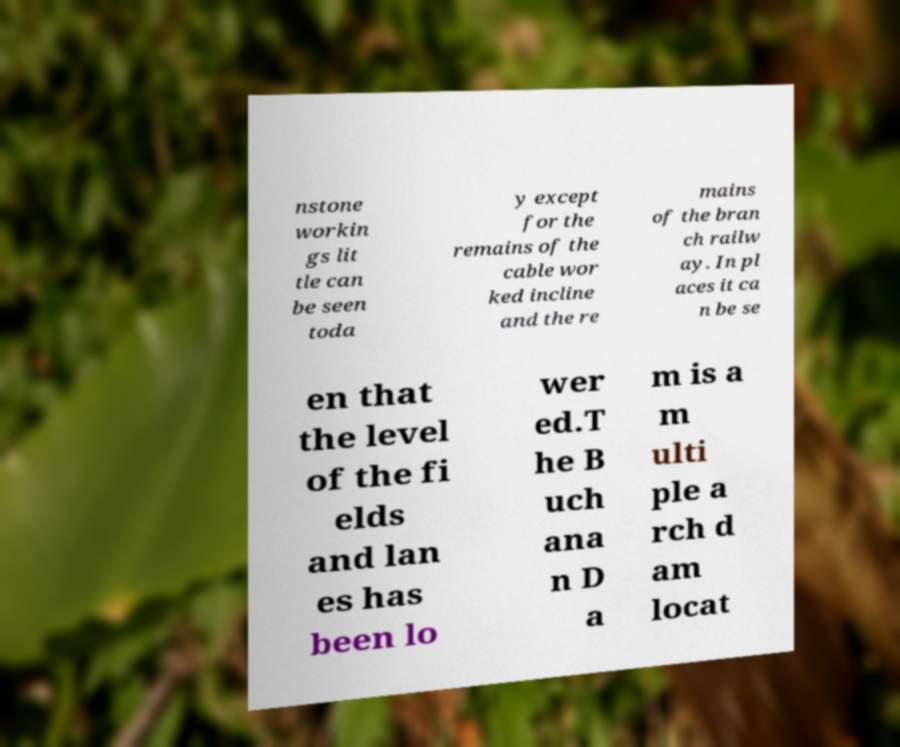Could you assist in decoding the text presented in this image and type it out clearly? nstone workin gs lit tle can be seen toda y except for the remains of the cable wor ked incline and the re mains of the bran ch railw ay. In pl aces it ca n be se en that the level of the fi elds and lan es has been lo wer ed.T he B uch ana n D a m is a m ulti ple a rch d am locat 